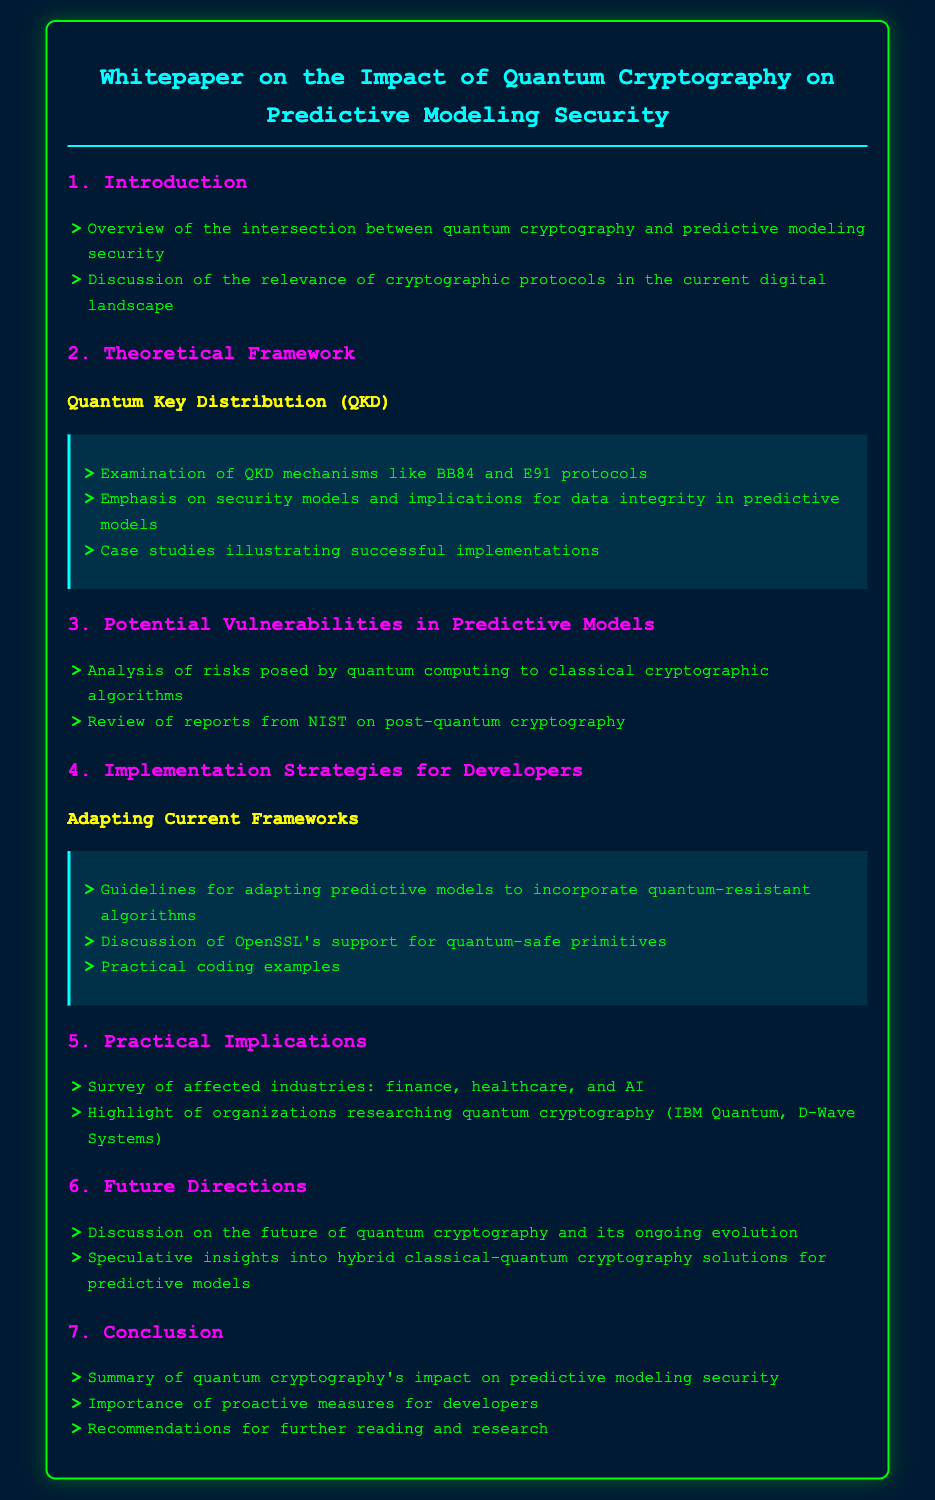What is the title of the document? The title of the document is mentioned in the header of the rendered document, providing a clear focus on the subject matter.
Answer: Whitepaper on the Impact of Quantum Cryptography on Predictive Modeling Security What are the two types of frameworks discussed in the document? The document divides the theoretical frameworks into specific sections, highlighting key areas of focus.
Answer: Quantum Key Distribution (QKD) and Implementation Strategies Which cryptographic protocols are examined under Quantum Key Distribution? The document lists specific protocols that are key to understanding the topic, which are essential to the discussion.
Answer: BB84 and E91 protocols What industries are surveyed in the Practical Implications section? The document explicitly mentions the industries that may be impacted by the discussed technologies, giving insight into practical applications.
Answer: Finance, healthcare, and AI What is a key guideline for developers regarding predictive models? The guidelines mentioned aim to help developers adapt to new security needs in predictive modeling, indicating best practices.
Answer: Incorporate quantum-resistant algorithms What aspect of quantum cryptography does section 6 focus on? The sixth section of the document speculates on future developments in the field, highlighting ongoing changes and advancements.
Answer: Future of quantum cryptography Which organization is highlighted for researching quantum cryptography? The document mentions specific organizations that are involved in quantum cryptography, indicating significant players in this field.
Answer: IBM Quantum What is the document's conclusion focused on? The conclusion summarizes the implications of the findings and underlines essential takeaways for the target audience.
Answer: Quantum cryptography's impact on predictive modeling security 